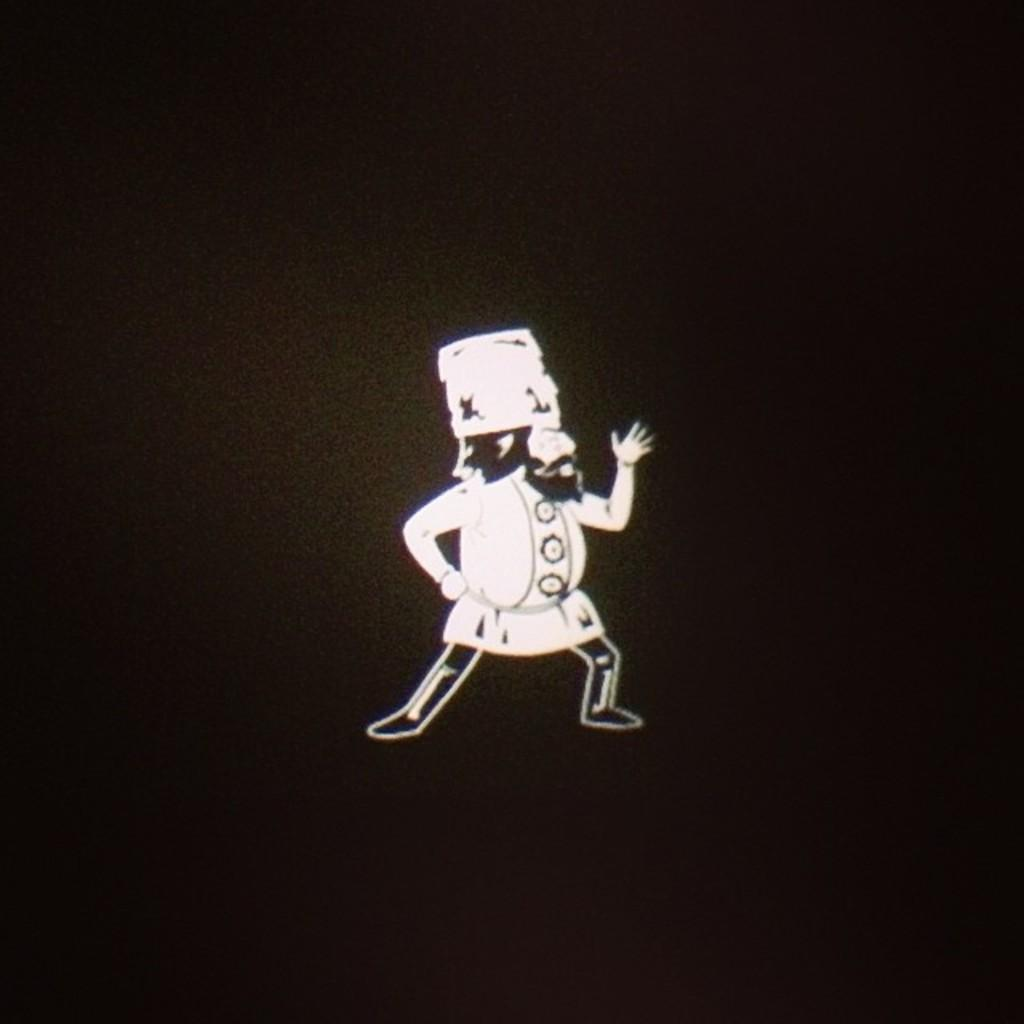What is the main subject of the image? There is a person in the image. What colors is the person wearing? The person is wearing black and white colors. What can be seen in the background of the image? The background of the image is black. What type of glove is the person wearing in the image? There is no glove visible in the image. What is the person writing with in the image? There is no pen or writing activity depicted in the image. 